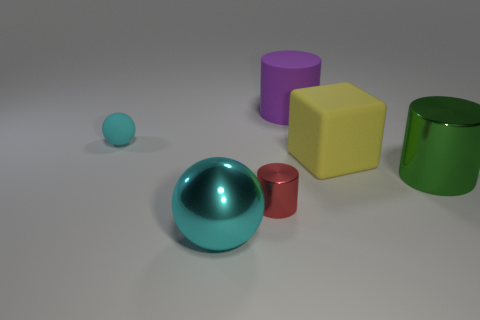Subtract all red cylinders. How many cylinders are left? 2 Add 1 large gray matte objects. How many objects exist? 7 Subtract all green cylinders. How many cylinders are left? 2 Subtract 1 cylinders. How many cylinders are left? 2 Subtract 0 purple blocks. How many objects are left? 6 Subtract all balls. How many objects are left? 4 Subtract all brown cylinders. Subtract all cyan spheres. How many cylinders are left? 3 Subtract all large red matte objects. Subtract all green metallic cylinders. How many objects are left? 5 Add 6 big metallic balls. How many big metallic balls are left? 7 Add 6 red cylinders. How many red cylinders exist? 7 